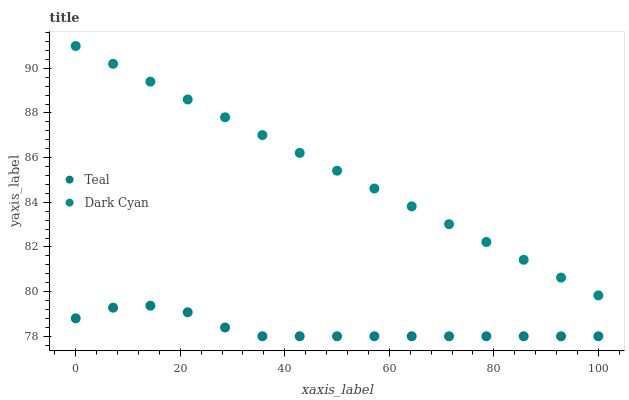Does Teal have the minimum area under the curve?
Answer yes or no. Yes. Does Dark Cyan have the maximum area under the curve?
Answer yes or no. Yes. Does Teal have the maximum area under the curve?
Answer yes or no. No. Is Dark Cyan the smoothest?
Answer yes or no. Yes. Is Teal the roughest?
Answer yes or no. Yes. Is Teal the smoothest?
Answer yes or no. No. Does Teal have the lowest value?
Answer yes or no. Yes. Does Dark Cyan have the highest value?
Answer yes or no. Yes. Does Teal have the highest value?
Answer yes or no. No. Is Teal less than Dark Cyan?
Answer yes or no. Yes. Is Dark Cyan greater than Teal?
Answer yes or no. Yes. Does Teal intersect Dark Cyan?
Answer yes or no. No. 